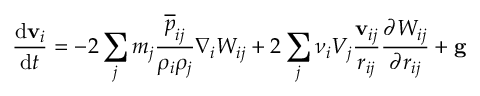Convert formula to latex. <formula><loc_0><loc_0><loc_500><loc_500>\frac { d v _ { i } } { d t } = - 2 \sum _ { j } m _ { j } \frac { \overline { p } _ { i j } } { \rho _ { i } \rho _ { j } } \nabla _ { i } W _ { i j } + 2 \sum _ { j } \nu _ { i } V _ { j } \frac { v _ { i j } } { r _ { i j } } \frac { \partial W _ { i j } } { \partial r _ { i j } } + g</formula> 